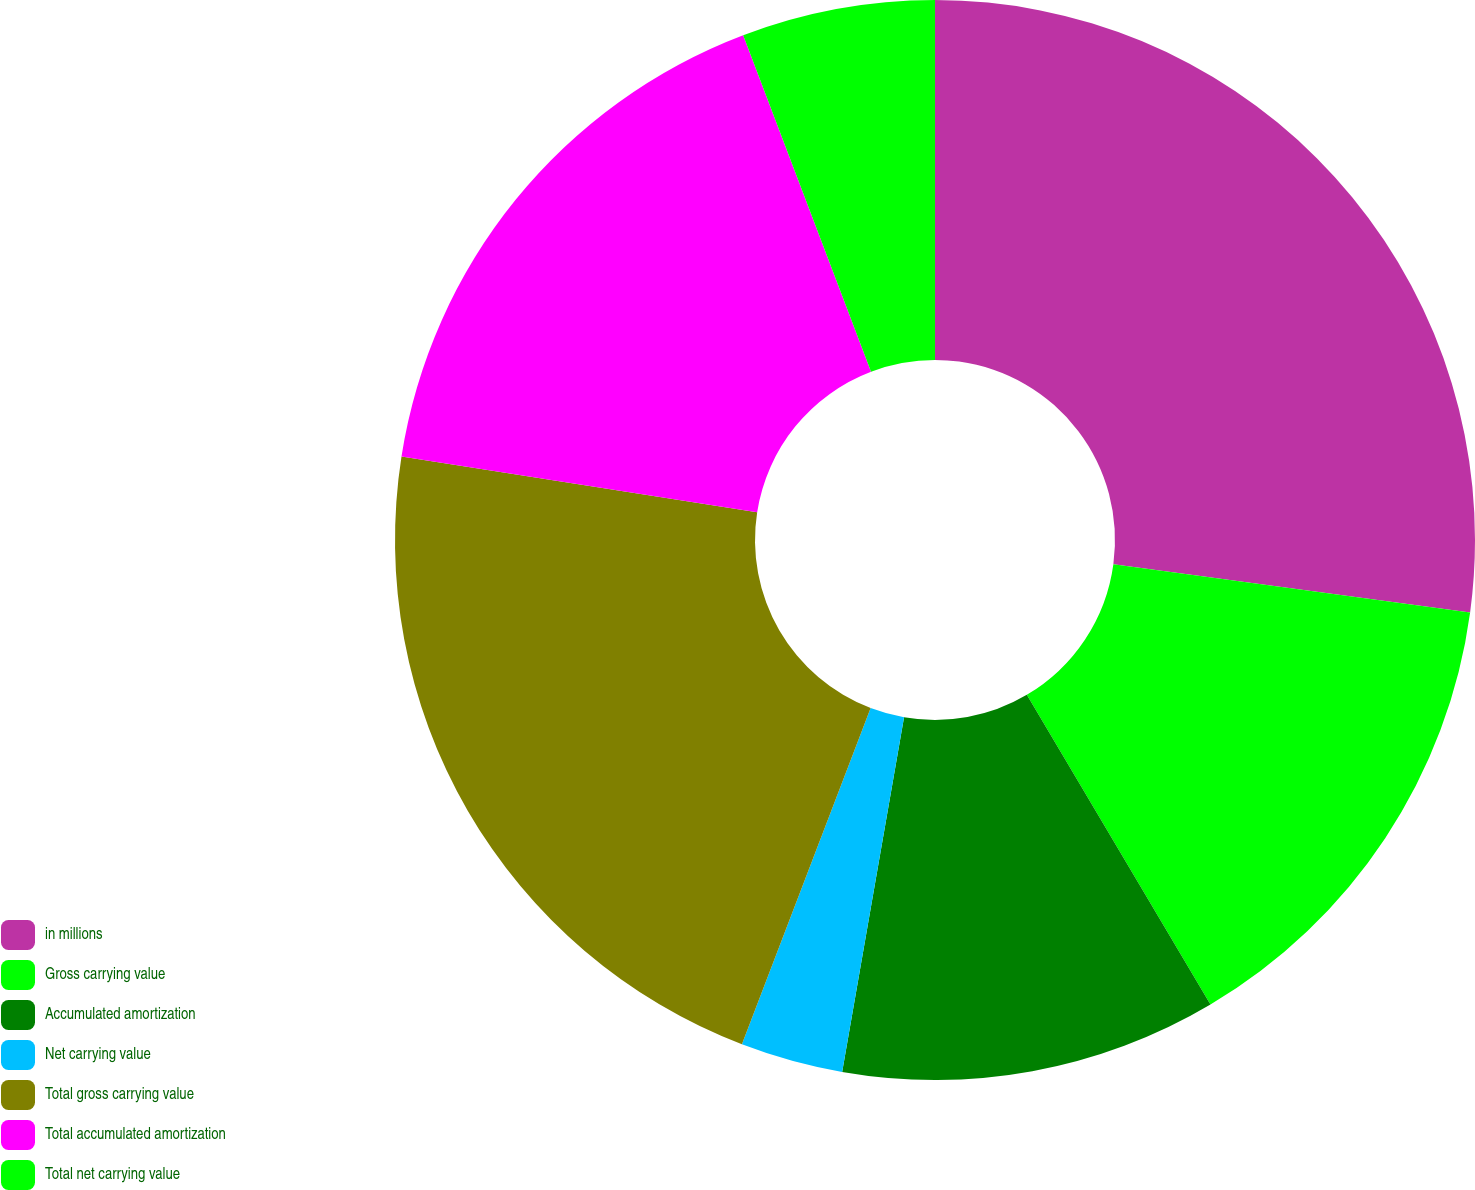Convert chart. <chart><loc_0><loc_0><loc_500><loc_500><pie_chart><fcel>in millions<fcel>Gross carrying value<fcel>Accumulated amortization<fcel>Net carrying value<fcel>Total gross carrying value<fcel>Total accumulated amortization<fcel>Total net carrying value<nl><fcel>27.14%<fcel>14.34%<fcel>11.27%<fcel>3.07%<fcel>21.65%<fcel>16.75%<fcel>5.78%<nl></chart> 